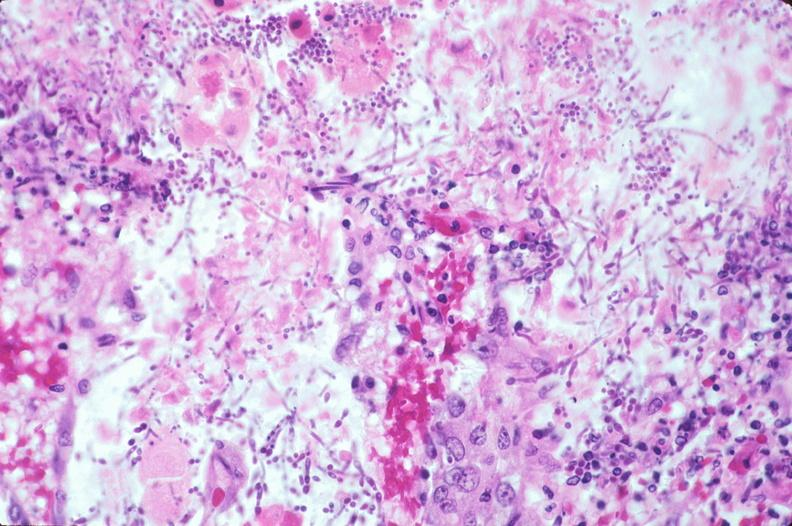what does this image show?
Answer the question using a single word or phrase. Duodenum 